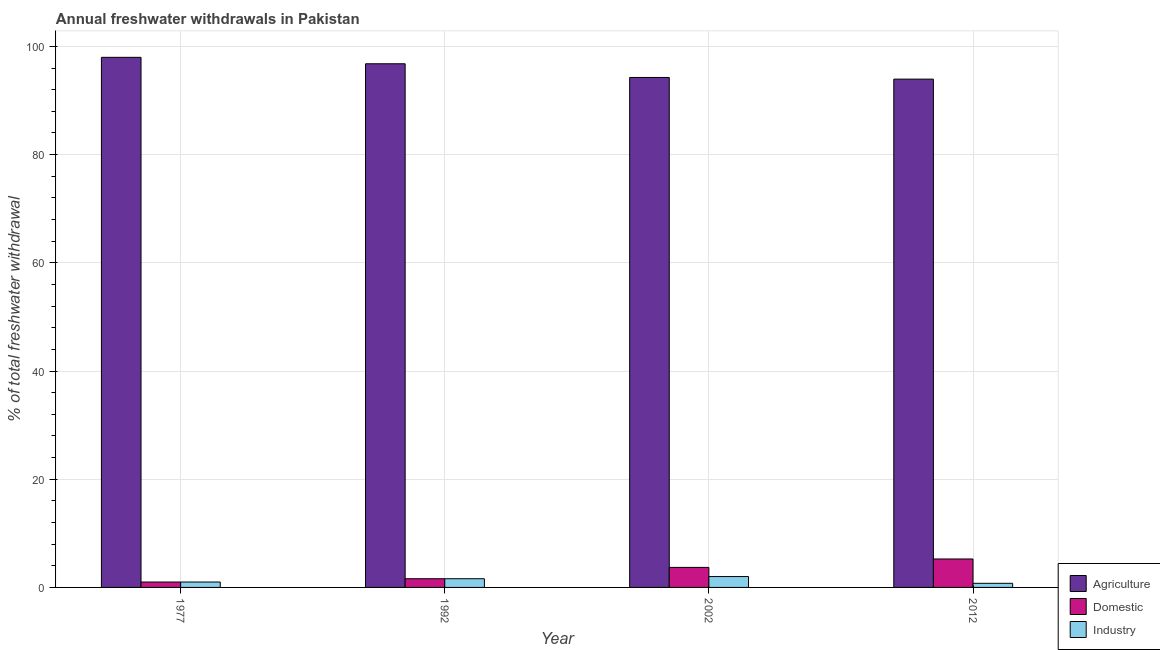Are the number of bars on each tick of the X-axis equal?
Keep it short and to the point. Yes. How many bars are there on the 3rd tick from the left?
Make the answer very short. 3. How many bars are there on the 4th tick from the right?
Offer a very short reply. 3. What is the percentage of freshwater withdrawal for industry in 1977?
Your answer should be very brief. 1. Across all years, what is the maximum percentage of freshwater withdrawal for industry?
Give a very brief answer. 2.01. In which year was the percentage of freshwater withdrawal for agriculture maximum?
Your answer should be compact. 1977. What is the total percentage of freshwater withdrawal for domestic purposes in the graph?
Give a very brief answer. 11.57. What is the difference between the percentage of freshwater withdrawal for industry in 1977 and that in 2002?
Your answer should be compact. -1.01. What is the difference between the percentage of freshwater withdrawal for domestic purposes in 1992 and the percentage of freshwater withdrawal for agriculture in 1977?
Provide a succinct answer. 0.61. What is the average percentage of freshwater withdrawal for industry per year?
Offer a terse response. 1.34. In the year 2002, what is the difference between the percentage of freshwater withdrawal for industry and percentage of freshwater withdrawal for agriculture?
Provide a short and direct response. 0. In how many years, is the percentage of freshwater withdrawal for agriculture greater than 96 %?
Make the answer very short. 2. What is the ratio of the percentage of freshwater withdrawal for agriculture in 1992 to that in 2002?
Your response must be concise. 1.03. What is the difference between the highest and the second highest percentage of freshwater withdrawal for domestic purposes?
Give a very brief answer. 1.56. What is the difference between the highest and the lowest percentage of freshwater withdrawal for industry?
Offer a very short reply. 1.25. In how many years, is the percentage of freshwater withdrawal for agriculture greater than the average percentage of freshwater withdrawal for agriculture taken over all years?
Provide a succinct answer. 2. Is the sum of the percentage of freshwater withdrawal for industry in 1992 and 2012 greater than the maximum percentage of freshwater withdrawal for domestic purposes across all years?
Provide a short and direct response. Yes. What does the 1st bar from the left in 2012 represents?
Make the answer very short. Agriculture. What does the 2nd bar from the right in 1992 represents?
Give a very brief answer. Domestic. Is it the case that in every year, the sum of the percentage of freshwater withdrawal for agriculture and percentage of freshwater withdrawal for domestic purposes is greater than the percentage of freshwater withdrawal for industry?
Offer a very short reply. Yes. How many bars are there?
Your answer should be very brief. 12. How many years are there in the graph?
Give a very brief answer. 4. What is the difference between two consecutive major ticks on the Y-axis?
Give a very brief answer. 20. Where does the legend appear in the graph?
Your response must be concise. Bottom right. How many legend labels are there?
Keep it short and to the point. 3. How are the legend labels stacked?
Give a very brief answer. Vertical. What is the title of the graph?
Offer a terse response. Annual freshwater withdrawals in Pakistan. Does "Textiles and clothing" appear as one of the legend labels in the graph?
Offer a terse response. No. What is the label or title of the X-axis?
Provide a short and direct response. Year. What is the label or title of the Y-axis?
Keep it short and to the point. % of total freshwater withdrawal. What is the % of total freshwater withdrawal of Agriculture in 1977?
Keep it short and to the point. 97.98. What is the % of total freshwater withdrawal of Industry in 1977?
Ensure brevity in your answer.  1. What is the % of total freshwater withdrawal in Agriculture in 1992?
Make the answer very short. 96.79. What is the % of total freshwater withdrawal in Domestic in 1992?
Provide a succinct answer. 1.61. What is the % of total freshwater withdrawal of Industry in 1992?
Provide a succinct answer. 1.61. What is the % of total freshwater withdrawal of Agriculture in 2002?
Ensure brevity in your answer.  94.26. What is the % of total freshwater withdrawal of Domestic in 2002?
Ensure brevity in your answer.  3.7. What is the % of total freshwater withdrawal of Industry in 2002?
Ensure brevity in your answer.  2.01. What is the % of total freshwater withdrawal in Agriculture in 2012?
Keep it short and to the point. 93.95. What is the % of total freshwater withdrawal of Domestic in 2012?
Keep it short and to the point. 5.26. What is the % of total freshwater withdrawal in Industry in 2012?
Offer a very short reply. 0.76. Across all years, what is the maximum % of total freshwater withdrawal in Agriculture?
Ensure brevity in your answer.  97.98. Across all years, what is the maximum % of total freshwater withdrawal in Domestic?
Offer a very short reply. 5.26. Across all years, what is the maximum % of total freshwater withdrawal of Industry?
Provide a succinct answer. 2.01. Across all years, what is the minimum % of total freshwater withdrawal in Agriculture?
Your answer should be very brief. 93.95. Across all years, what is the minimum % of total freshwater withdrawal of Industry?
Keep it short and to the point. 0.76. What is the total % of total freshwater withdrawal of Agriculture in the graph?
Offer a terse response. 382.98. What is the total % of total freshwater withdrawal of Domestic in the graph?
Give a very brief answer. 11.57. What is the total % of total freshwater withdrawal in Industry in the graph?
Keep it short and to the point. 5.38. What is the difference between the % of total freshwater withdrawal in Agriculture in 1977 and that in 1992?
Keep it short and to the point. 1.19. What is the difference between the % of total freshwater withdrawal in Domestic in 1977 and that in 1992?
Your answer should be very brief. -0.61. What is the difference between the % of total freshwater withdrawal of Industry in 1977 and that in 1992?
Keep it short and to the point. -0.61. What is the difference between the % of total freshwater withdrawal in Agriculture in 1977 and that in 2002?
Ensure brevity in your answer.  3.72. What is the difference between the % of total freshwater withdrawal of Domestic in 1977 and that in 2002?
Ensure brevity in your answer.  -2.7. What is the difference between the % of total freshwater withdrawal of Industry in 1977 and that in 2002?
Your answer should be compact. -1.01. What is the difference between the % of total freshwater withdrawal of Agriculture in 1977 and that in 2012?
Offer a terse response. 4.03. What is the difference between the % of total freshwater withdrawal in Domestic in 1977 and that in 2012?
Keep it short and to the point. -4.26. What is the difference between the % of total freshwater withdrawal in Industry in 1977 and that in 2012?
Ensure brevity in your answer.  0.24. What is the difference between the % of total freshwater withdrawal in Agriculture in 1992 and that in 2002?
Your response must be concise. 2.53. What is the difference between the % of total freshwater withdrawal in Domestic in 1992 and that in 2002?
Provide a succinct answer. -2.1. What is the difference between the % of total freshwater withdrawal of Industry in 1992 and that in 2002?
Provide a succinct answer. -0.4. What is the difference between the % of total freshwater withdrawal in Agriculture in 1992 and that in 2012?
Ensure brevity in your answer.  2.84. What is the difference between the % of total freshwater withdrawal in Domestic in 1992 and that in 2012?
Offer a very short reply. -3.65. What is the difference between the % of total freshwater withdrawal of Industry in 1992 and that in 2012?
Ensure brevity in your answer.  0.84. What is the difference between the % of total freshwater withdrawal of Agriculture in 2002 and that in 2012?
Give a very brief answer. 0.31. What is the difference between the % of total freshwater withdrawal of Domestic in 2002 and that in 2012?
Ensure brevity in your answer.  -1.56. What is the difference between the % of total freshwater withdrawal of Industry in 2002 and that in 2012?
Make the answer very short. 1.25. What is the difference between the % of total freshwater withdrawal of Agriculture in 1977 and the % of total freshwater withdrawal of Domestic in 1992?
Offer a very short reply. 96.37. What is the difference between the % of total freshwater withdrawal in Agriculture in 1977 and the % of total freshwater withdrawal in Industry in 1992?
Ensure brevity in your answer.  96.37. What is the difference between the % of total freshwater withdrawal of Domestic in 1977 and the % of total freshwater withdrawal of Industry in 1992?
Make the answer very short. -0.61. What is the difference between the % of total freshwater withdrawal of Agriculture in 1977 and the % of total freshwater withdrawal of Domestic in 2002?
Your answer should be very brief. 94.28. What is the difference between the % of total freshwater withdrawal in Agriculture in 1977 and the % of total freshwater withdrawal in Industry in 2002?
Keep it short and to the point. 95.97. What is the difference between the % of total freshwater withdrawal in Domestic in 1977 and the % of total freshwater withdrawal in Industry in 2002?
Offer a terse response. -1.01. What is the difference between the % of total freshwater withdrawal of Agriculture in 1977 and the % of total freshwater withdrawal of Domestic in 2012?
Provide a succinct answer. 92.72. What is the difference between the % of total freshwater withdrawal of Agriculture in 1977 and the % of total freshwater withdrawal of Industry in 2012?
Your response must be concise. 97.22. What is the difference between the % of total freshwater withdrawal of Domestic in 1977 and the % of total freshwater withdrawal of Industry in 2012?
Your answer should be very brief. 0.24. What is the difference between the % of total freshwater withdrawal of Agriculture in 1992 and the % of total freshwater withdrawal of Domestic in 2002?
Your answer should be compact. 93.09. What is the difference between the % of total freshwater withdrawal of Agriculture in 1992 and the % of total freshwater withdrawal of Industry in 2002?
Provide a short and direct response. 94.78. What is the difference between the % of total freshwater withdrawal of Domestic in 1992 and the % of total freshwater withdrawal of Industry in 2002?
Provide a succinct answer. -0.4. What is the difference between the % of total freshwater withdrawal of Agriculture in 1992 and the % of total freshwater withdrawal of Domestic in 2012?
Give a very brief answer. 91.53. What is the difference between the % of total freshwater withdrawal in Agriculture in 1992 and the % of total freshwater withdrawal in Industry in 2012?
Provide a short and direct response. 96.03. What is the difference between the % of total freshwater withdrawal of Domestic in 1992 and the % of total freshwater withdrawal of Industry in 2012?
Provide a succinct answer. 0.84. What is the difference between the % of total freshwater withdrawal of Agriculture in 2002 and the % of total freshwater withdrawal of Domestic in 2012?
Your response must be concise. 89. What is the difference between the % of total freshwater withdrawal in Agriculture in 2002 and the % of total freshwater withdrawal in Industry in 2012?
Make the answer very short. 93.5. What is the difference between the % of total freshwater withdrawal in Domestic in 2002 and the % of total freshwater withdrawal in Industry in 2012?
Your response must be concise. 2.94. What is the average % of total freshwater withdrawal of Agriculture per year?
Offer a terse response. 95.75. What is the average % of total freshwater withdrawal of Domestic per year?
Give a very brief answer. 2.89. What is the average % of total freshwater withdrawal of Industry per year?
Offer a terse response. 1.34. In the year 1977, what is the difference between the % of total freshwater withdrawal of Agriculture and % of total freshwater withdrawal of Domestic?
Offer a very short reply. 96.98. In the year 1977, what is the difference between the % of total freshwater withdrawal in Agriculture and % of total freshwater withdrawal in Industry?
Provide a short and direct response. 96.98. In the year 1977, what is the difference between the % of total freshwater withdrawal in Domestic and % of total freshwater withdrawal in Industry?
Give a very brief answer. 0. In the year 1992, what is the difference between the % of total freshwater withdrawal of Agriculture and % of total freshwater withdrawal of Domestic?
Ensure brevity in your answer.  95.18. In the year 1992, what is the difference between the % of total freshwater withdrawal in Agriculture and % of total freshwater withdrawal in Industry?
Give a very brief answer. 95.18. In the year 1992, what is the difference between the % of total freshwater withdrawal of Domestic and % of total freshwater withdrawal of Industry?
Provide a short and direct response. 0. In the year 2002, what is the difference between the % of total freshwater withdrawal of Agriculture and % of total freshwater withdrawal of Domestic?
Offer a very short reply. 90.56. In the year 2002, what is the difference between the % of total freshwater withdrawal in Agriculture and % of total freshwater withdrawal in Industry?
Your response must be concise. 92.25. In the year 2002, what is the difference between the % of total freshwater withdrawal in Domestic and % of total freshwater withdrawal in Industry?
Offer a terse response. 1.69. In the year 2012, what is the difference between the % of total freshwater withdrawal in Agriculture and % of total freshwater withdrawal in Domestic?
Keep it short and to the point. 88.69. In the year 2012, what is the difference between the % of total freshwater withdrawal in Agriculture and % of total freshwater withdrawal in Industry?
Offer a very short reply. 93.19. In the year 2012, what is the difference between the % of total freshwater withdrawal of Domestic and % of total freshwater withdrawal of Industry?
Offer a terse response. 4.5. What is the ratio of the % of total freshwater withdrawal in Agriculture in 1977 to that in 1992?
Provide a succinct answer. 1.01. What is the ratio of the % of total freshwater withdrawal in Domestic in 1977 to that in 1992?
Provide a short and direct response. 0.62. What is the ratio of the % of total freshwater withdrawal of Industry in 1977 to that in 1992?
Give a very brief answer. 0.62. What is the ratio of the % of total freshwater withdrawal of Agriculture in 1977 to that in 2002?
Ensure brevity in your answer.  1.04. What is the ratio of the % of total freshwater withdrawal of Domestic in 1977 to that in 2002?
Your answer should be compact. 0.27. What is the ratio of the % of total freshwater withdrawal in Industry in 1977 to that in 2002?
Offer a very short reply. 0.5. What is the ratio of the % of total freshwater withdrawal in Agriculture in 1977 to that in 2012?
Provide a short and direct response. 1.04. What is the ratio of the % of total freshwater withdrawal in Domestic in 1977 to that in 2012?
Make the answer very short. 0.19. What is the ratio of the % of total freshwater withdrawal in Industry in 1977 to that in 2012?
Ensure brevity in your answer.  1.31. What is the ratio of the % of total freshwater withdrawal of Agriculture in 1992 to that in 2002?
Your response must be concise. 1.03. What is the ratio of the % of total freshwater withdrawal in Domestic in 1992 to that in 2002?
Make the answer very short. 0.43. What is the ratio of the % of total freshwater withdrawal of Industry in 1992 to that in 2002?
Offer a terse response. 0.8. What is the ratio of the % of total freshwater withdrawal in Agriculture in 1992 to that in 2012?
Provide a succinct answer. 1.03. What is the ratio of the % of total freshwater withdrawal of Domestic in 1992 to that in 2012?
Make the answer very short. 0.31. What is the ratio of the % of total freshwater withdrawal in Industry in 1992 to that in 2012?
Provide a succinct answer. 2.11. What is the ratio of the % of total freshwater withdrawal in Agriculture in 2002 to that in 2012?
Give a very brief answer. 1. What is the ratio of the % of total freshwater withdrawal of Domestic in 2002 to that in 2012?
Offer a terse response. 0.7. What is the ratio of the % of total freshwater withdrawal in Industry in 2002 to that in 2012?
Offer a terse response. 2.63. What is the difference between the highest and the second highest % of total freshwater withdrawal of Agriculture?
Provide a succinct answer. 1.19. What is the difference between the highest and the second highest % of total freshwater withdrawal of Domestic?
Give a very brief answer. 1.56. What is the difference between the highest and the second highest % of total freshwater withdrawal in Industry?
Provide a succinct answer. 0.4. What is the difference between the highest and the lowest % of total freshwater withdrawal of Agriculture?
Keep it short and to the point. 4.03. What is the difference between the highest and the lowest % of total freshwater withdrawal in Domestic?
Your response must be concise. 4.26. What is the difference between the highest and the lowest % of total freshwater withdrawal in Industry?
Ensure brevity in your answer.  1.25. 